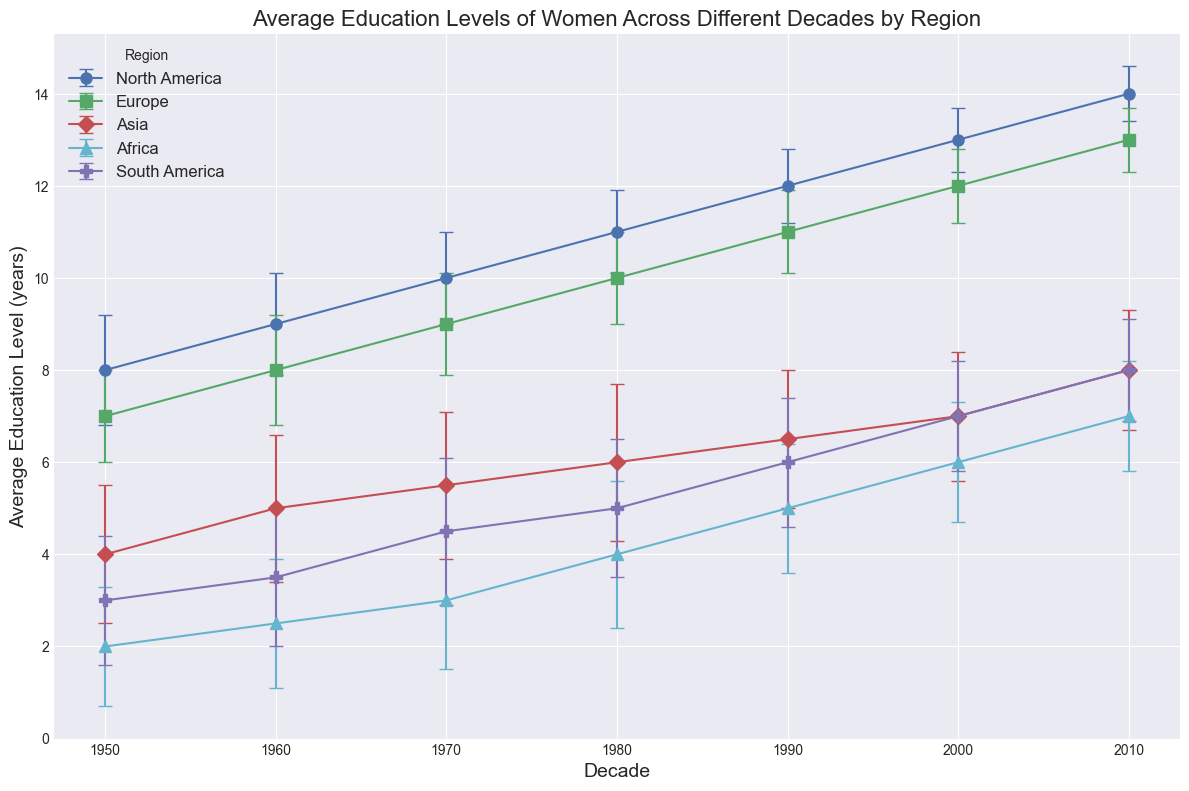What decade shows the highest average education level of women in South America? The highest average education level for South America can be identified by looking at the line representing South America and identifying the decade with the highest point on that line. The highest point is 8 years in 2010.
Answer: 2010 How much did the average education level of women in Asia increase from 1950 to 2010? To find this, subtract the average education level in 1950 from the one in 2010 for Asia. It increased from 4 years in 1950 to 8 years in 2010. Therefore, the increase is 8 - 4 = 4 years.
Answer: 4 years Which region had the least increase in average education level of women between 1950 and 2010? Calculate the increase for each region by subtracting the 1950 average from the 2010 average. North America: 14-8 = 6, Europe: 13-7 = 6, Asia: 8-4 = 4, Africa: 7-2 = 5, South America: 8-3 = 5. Asia had the least increase with 4 years.
Answer: Asia In which decade did Europe surpass North America in average education levels of women, if at all? Compare the average education levels of women by looking at the plot points for Europe and North America over the decades. Europe never surpassed North America in any decade.
Answer: Never What is the difference in average education levels of women between Africa and Europe in the 1990s? Find the values for Africa and Europe in the 1990s and subtract the African value from the European value: 11 - 5 = 6 years.
Answer: 6 years During which decade did Africa show the greatest increase in women's education level compared to the previous decade? Compare the increase in education levels for Africa across the decades: from 1950 to 1960 it increased by 0.5 years, from 1960 to 1970 by 0.5 years, from 1970 to 1980 by 1 year, from 1980 to 1990 by 1 year, and from 1990 to 2000 by 1 year. However, from 2000 to 2010 it increased by 1 year, equal to 1980 -> 1990 and 1990 -> 2000. So, the greatest increase occurred in either 1980s, 1990s, and 2000s, by 1 year each.
Answer: 1980s, 1990s, 2000s How do the average education levels of women in North America in 1950 compare to Asia in 2010? Compare the education level of North America in 1950 (8 years) with Asia in 2010 (8 years). Both are equal.
Answer: Equal What was the overall trend in the average education level of women in Africa from 1950 to 2010? Look at the trend line for Africa from 1950 to 2010 to describe whether it increases, decreases, or stays constant. It shows a consistent increase from 2 years in 1950 to 7 years in 2010.
Answer: Increasing Between Asia and South America, which region saw a higher average education level for women in the 1960s? Compare the average education levels of Asia and South America in the 1960s. Asia is at 5 years, and South America is at 3.5 years. Asia has a higher value.
Answer: Asia What decade marked the largest increase in average education levels for women in Europe? To find the decade with the largest increase, calculate the difference between each consecutive decade for Europe. From 1950 to 1960 is 1 year, 1960 to 1970 is 1 year, 1970 to 1980 is 1 year, 1980 to 1990 is 1 year, 1990 to 2000 is 1 year, and 2000 to 2010 is 1 year. All decades show an increase of 1 year, so no single decade stands out.
Answer: All decades marked the same increase 